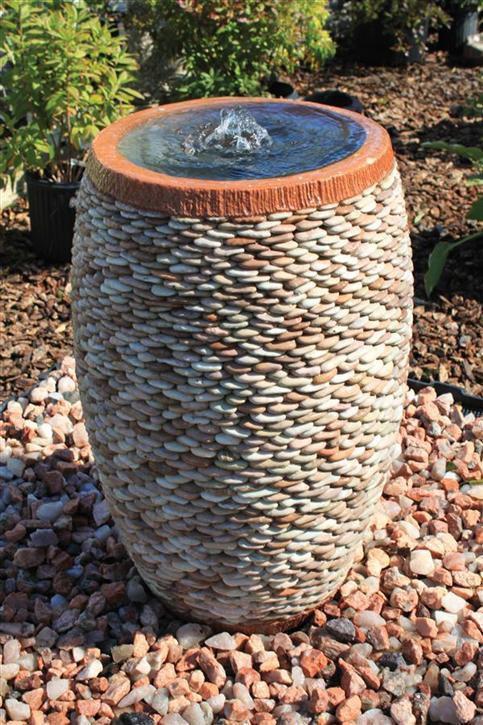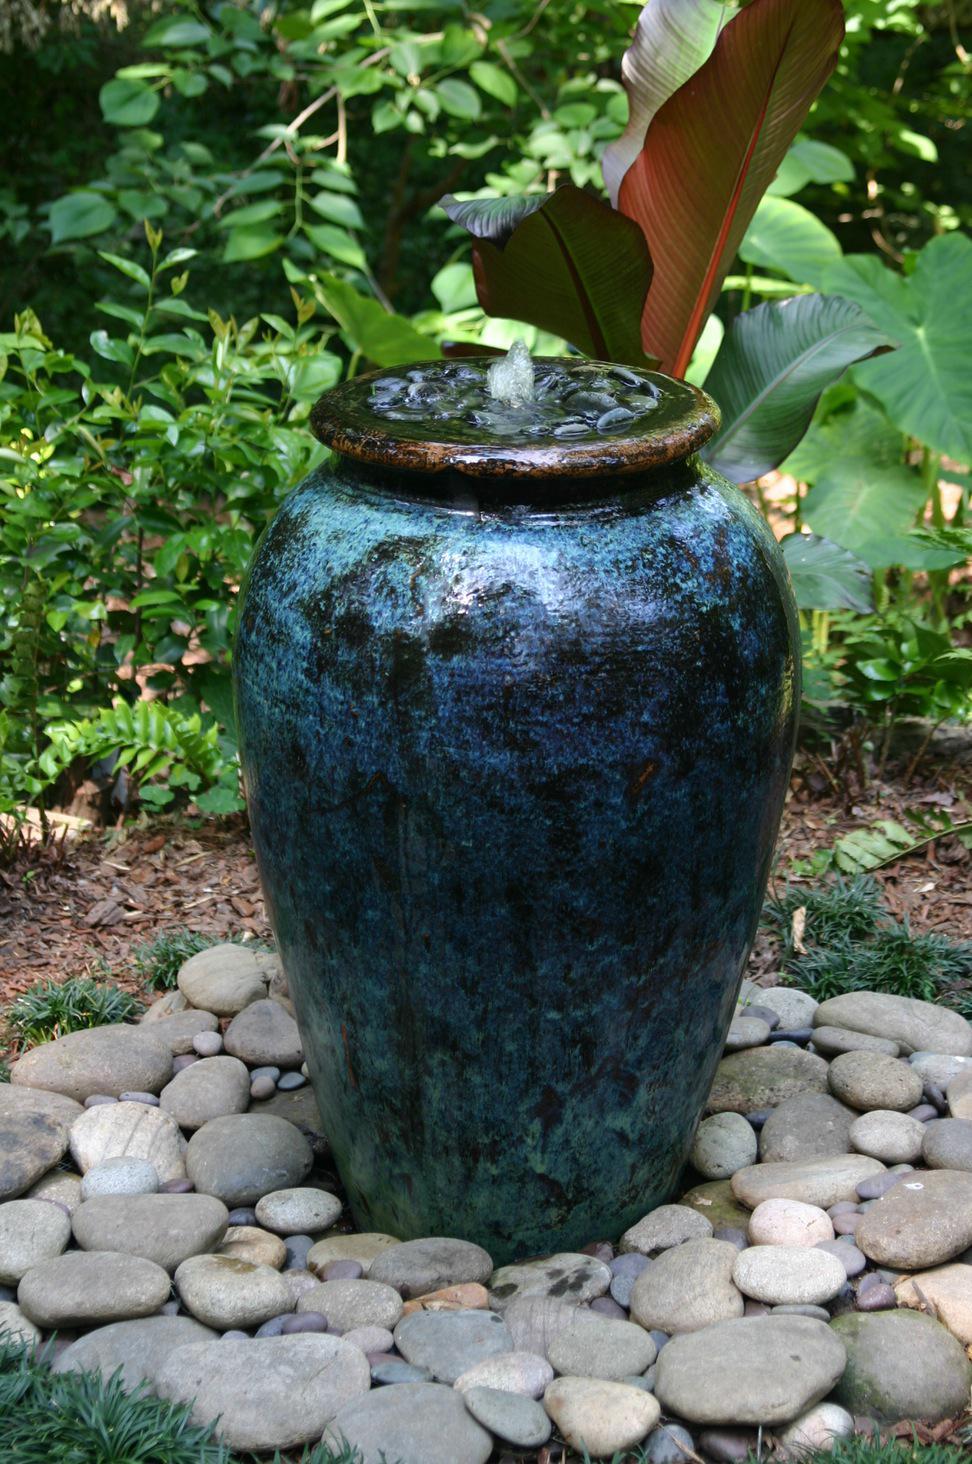The first image is the image on the left, the second image is the image on the right. For the images shown, is this caption "Each image features exactly one upright pottery vessel." true? Answer yes or no. Yes. The first image is the image on the left, the second image is the image on the right. For the images shown, is this caption "Two large urn shaped pots are placed in outdoor garden settings, with at least one being used as a water fountain." true? Answer yes or no. Yes. 